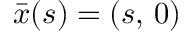<formula> <loc_0><loc_0><loc_500><loc_500>\bar { x } ( s ) = ( s , \, 0 )</formula> 